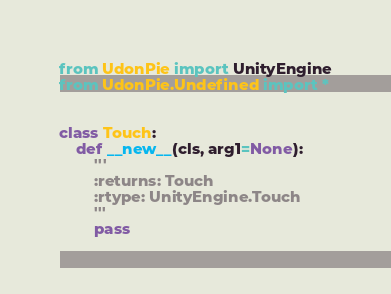<code> <loc_0><loc_0><loc_500><loc_500><_Python_>from UdonPie import UnityEngine
from UdonPie.Undefined import *


class Touch:
    def __new__(cls, arg1=None):
        '''
        :returns: Touch
        :rtype: UnityEngine.Touch
        '''
        pass
</code> 